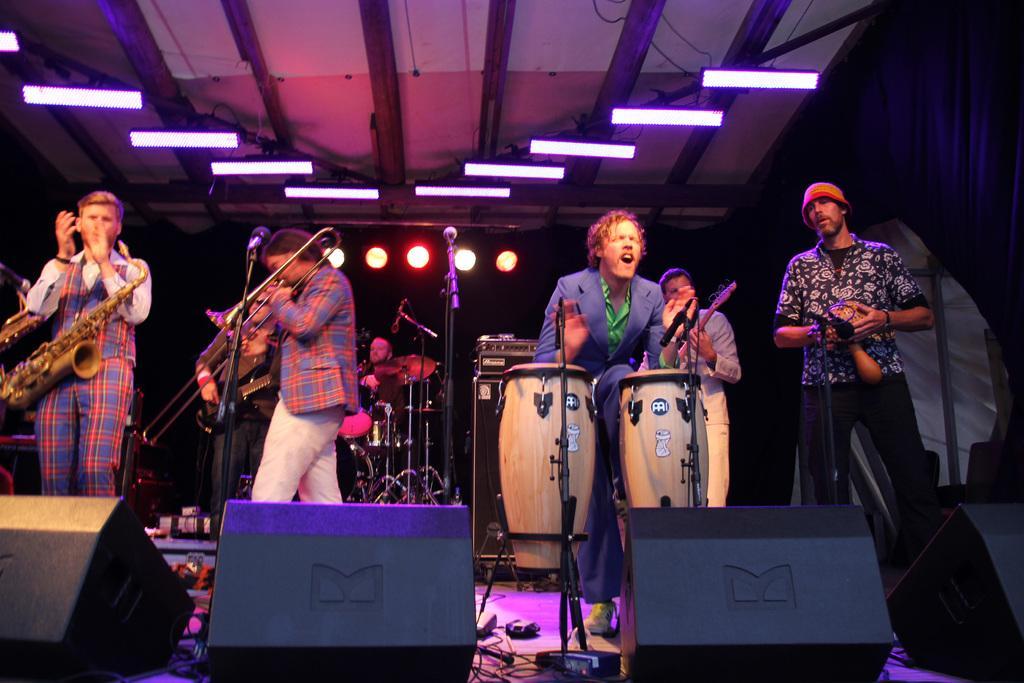Please provide a concise description of this image. On this stage this group of people are playing musical instruments in-front of mic. On top there are lights and focusing lights. Far there are musical instruments. On floor there are devices and cables. 